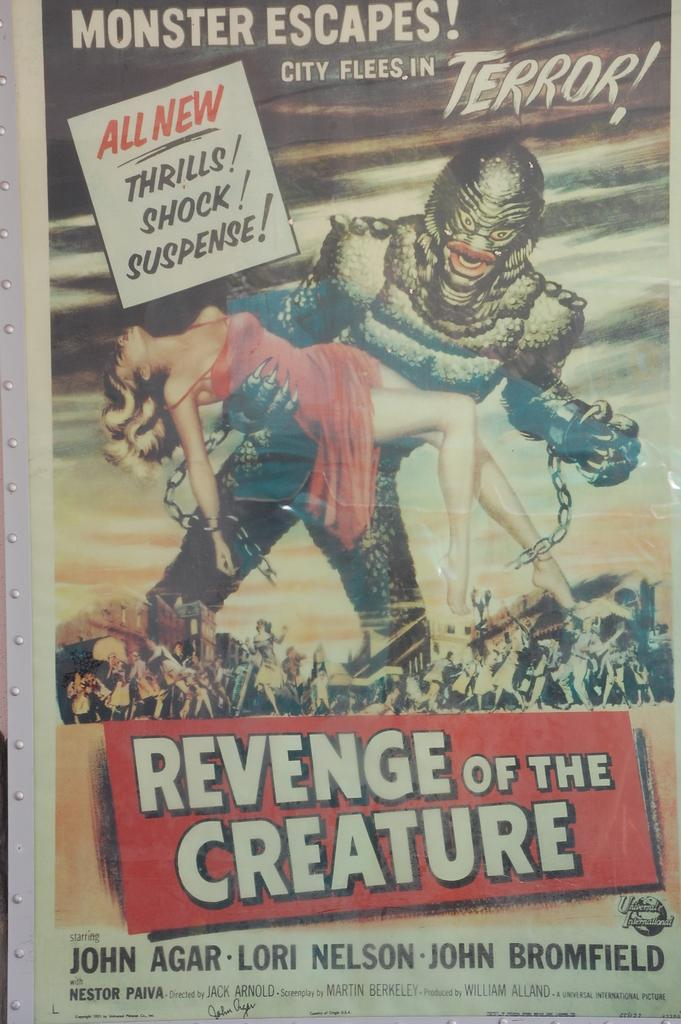<image>
Summarize the visual content of the image. A retro poster for a classic movie called Revenge of the Creature shows a monster terrorizing fleeing people while holding an unconscious woman. 